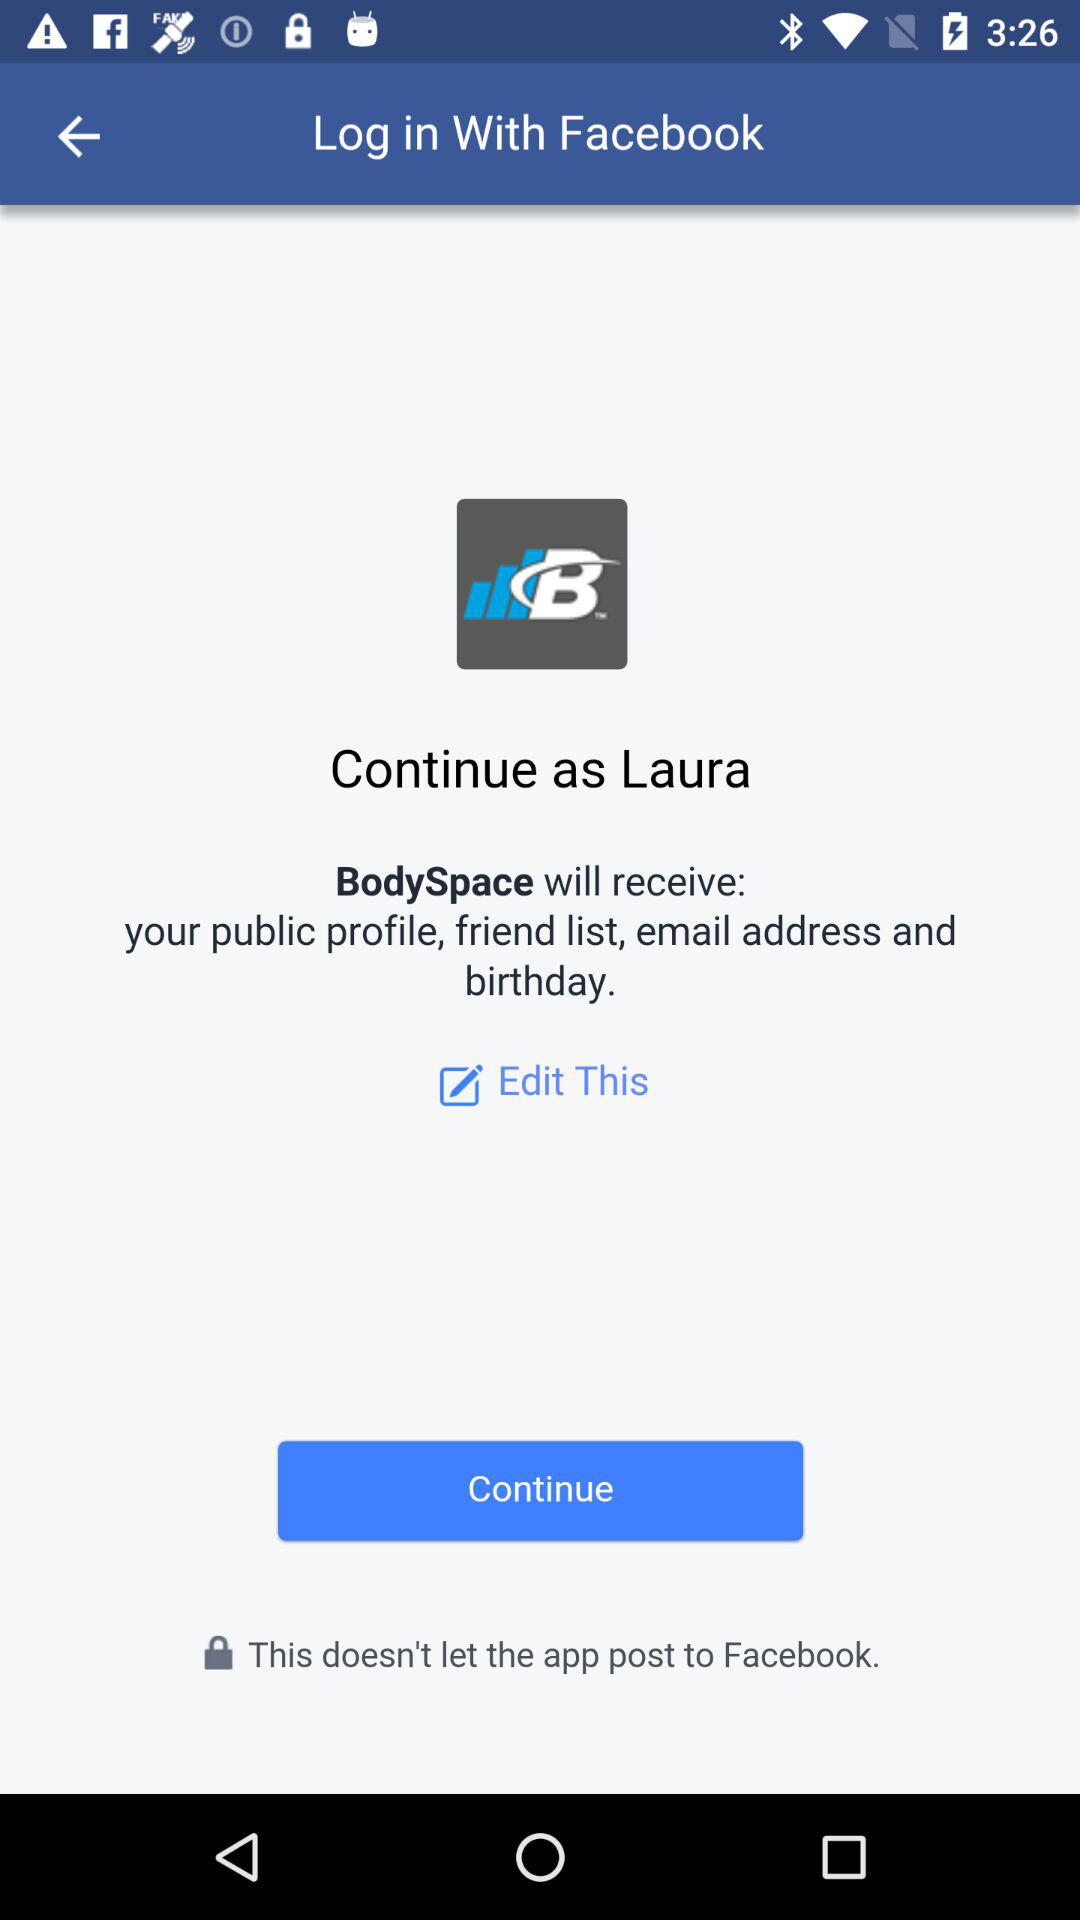Where does Laura live?
When the provided information is insufficient, respond with <no answer>. <no answer> 